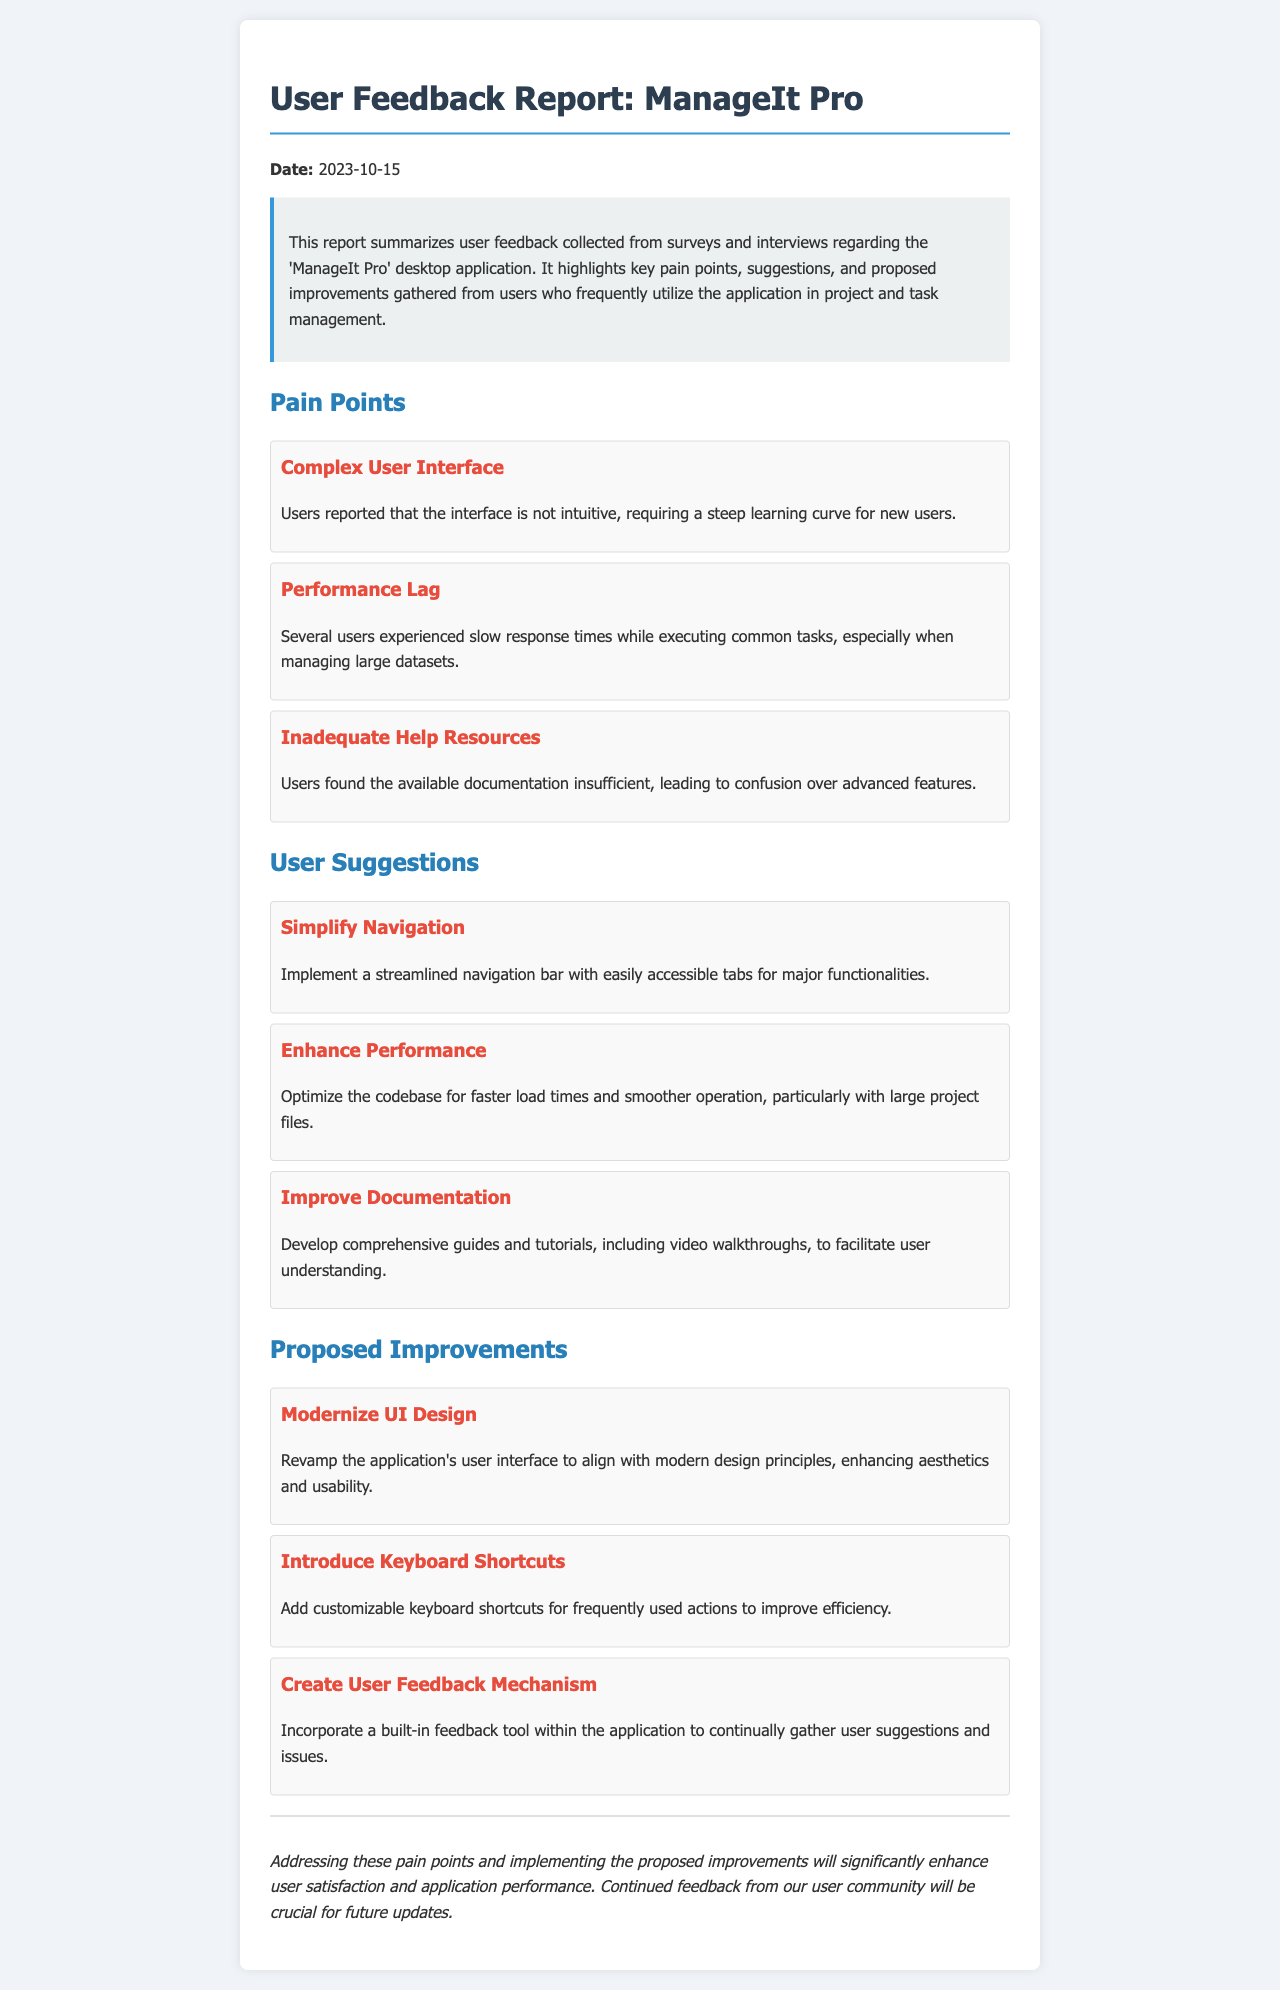What is the date of the report? The date of the report is explicitly mentioned in the document, which is 2023-10-15.
Answer: 2023-10-15 What is the first pain point mentioned? The first pain point listed in the document is "Complex User Interface," which is highlighted in the section on pain points.
Answer: Complex User Interface What user suggestion involves navigation? The suggestion related to navigation is "Simplify Navigation," as stated under the user suggestions section of the document.
Answer: Simplify Navigation What is the proposed improvement related to the application design? The proposed improvement concerning design is "Modernize UI Design," which is noted in the proposed improvements section.
Answer: Modernize UI Design How many pain points are listed in the document? The document lists three pain points in the section dedicated to pain points.
Answer: 3 What is one way users suggested to improve performance? Users suggested to "Enhance Performance" by optimizing the codebase for better speed and efficiency.
Answer: Enhance Performance What should be included in the new documentation according to user suggestions? Users suggested that the new documentation should include "comprehensive guides and tutorials," especially video walkthroughs.
Answer: comprehensive guides and tutorials What mechanism is proposed for ongoing user feedback? The document proposes to "Create User Feedback Mechanism" to gather user suggestions and issues continuously.
Answer: Create User Feedback Mechanism What summarizes the feedback report? The summary of the feedback report is contained in a paragraph right after the title, encapsulating user feedback and its significance.
Answer: summarizing user feedback 